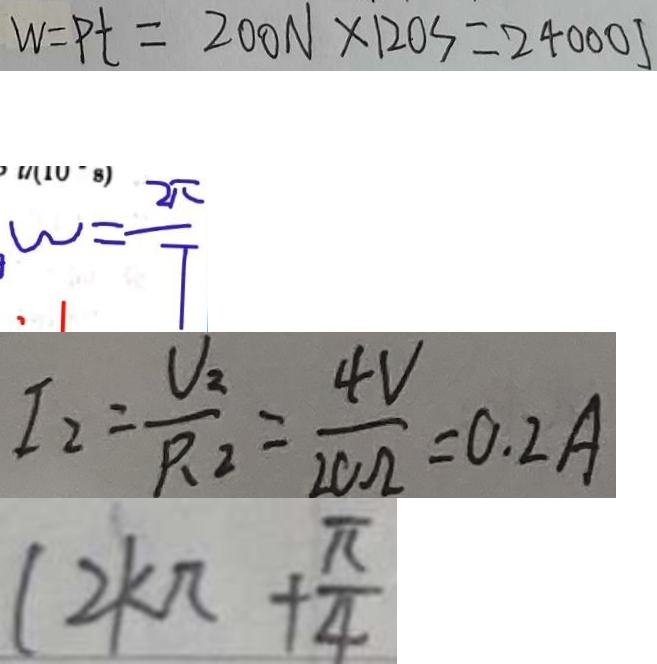<formula> <loc_0><loc_0><loc_500><loc_500>W = P t = 2 0 0 N \times 1 2 0 s = 2 4 0 0 0 J 
 \omega = \frac { 2 \pi } { T } 
 I _ { 2 } = \frac { U _ { 2 } } { P _ { 2 } } = \frac { 4 V } { 2 0 \Omega } = 0 . 2 A 
 ( 2 k \pi + \frac { \pi } { 4 }</formula> 